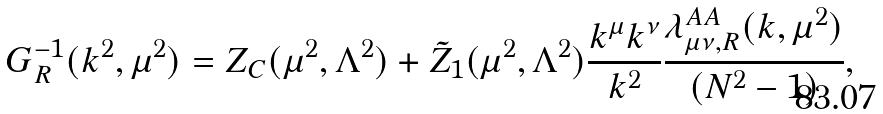Convert formula to latex. <formula><loc_0><loc_0><loc_500><loc_500>G _ { R } ^ { - 1 } ( k ^ { 2 } , \mu ^ { 2 } ) = Z _ { C } ( \mu ^ { 2 } , \Lambda ^ { 2 } ) + \tilde { Z } _ { 1 } ( \mu ^ { 2 } , \Lambda ^ { 2 } ) \frac { k ^ { \mu } k ^ { \nu } } { k ^ { 2 } } \frac { \lambda _ { \mu \nu , R } ^ { A A } ( k , \mu ^ { 2 } ) } { ( N ^ { 2 } - 1 ) } ,</formula> 